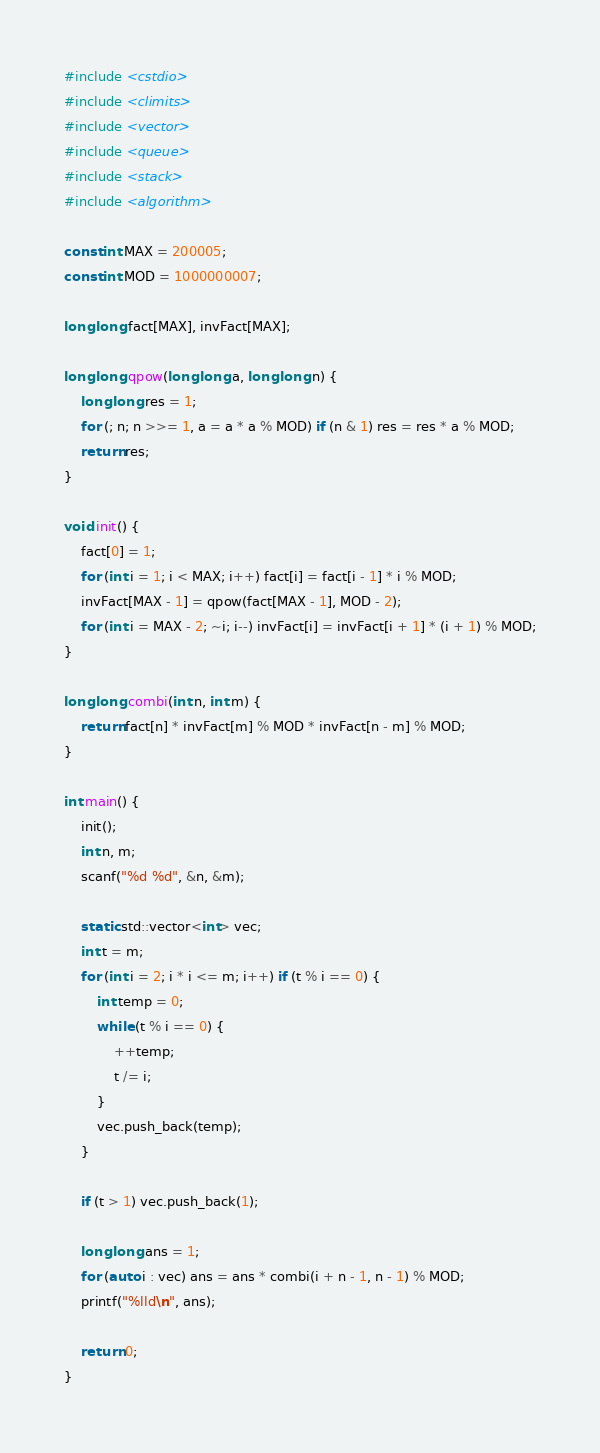<code> <loc_0><loc_0><loc_500><loc_500><_C++_>#include <cstdio>
#include <climits>
#include <vector>
#include <queue>
#include <stack>
#include <algorithm>

const int MAX = 200005;
const int MOD = 1000000007;

long long fact[MAX], invFact[MAX];

long long qpow(long long a, long long n) {
    long long res = 1;
    for (; n; n >>= 1, a = a * a % MOD) if (n & 1) res = res * a % MOD;
    return res;
}

void init() {
    fact[0] = 1;
    for (int i = 1; i < MAX; i++) fact[i] = fact[i - 1] * i % MOD;
    invFact[MAX - 1] = qpow(fact[MAX - 1], MOD - 2);
    for (int i = MAX - 2; ~i; i--) invFact[i] = invFact[i + 1] * (i + 1) % MOD;
}

long long combi(int n, int m) {
    return fact[n] * invFact[m] % MOD * invFact[n - m] % MOD;
}

int main() {
    init();
    int n, m;
    scanf("%d %d", &n, &m);

    static std::vector<int> vec;
    int t = m;
    for (int i = 2; i * i <= m; i++) if (t % i == 0) {
        int temp = 0;
        while (t % i == 0) {
            ++temp;
            t /= i;
        }
        vec.push_back(temp);
    }

    if (t > 1) vec.push_back(1);

    long long ans = 1;
    for (auto i : vec) ans = ans * combi(i + n - 1, n - 1) % MOD;
    printf("%lld\n", ans);

    return 0;
}</code> 